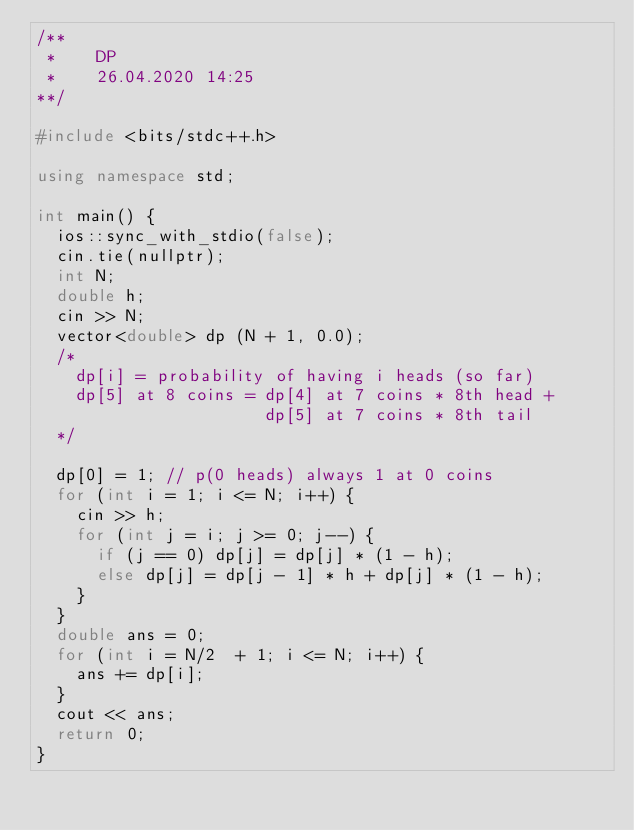<code> <loc_0><loc_0><loc_500><loc_500><_C++_>/**
 *    DP
 *    26.04.2020 14:25
**/

#include <bits/stdc++.h>

using namespace std;

int main() {
  ios::sync_with_stdio(false);
  cin.tie(nullptr);
  int N;
  double h;
  cin >> N;
  vector<double> dp (N + 1, 0.0);
  /*
    dp[i] = probability of having i heads (so far)
    dp[5] at 8 coins = dp[4] at 7 coins * 8th head + 
                       dp[5] at 7 coins * 8th tail
  */
  
  dp[0] = 1; // p(0 heads) always 1 at 0 coins
  for (int i = 1; i <= N; i++) {
    cin >> h;
    for (int j = i; j >= 0; j--) {
      if (j == 0) dp[j] = dp[j] * (1 - h);
      else dp[j] = dp[j - 1] * h + dp[j] * (1 - h);
    }
  }
  double ans = 0;
  for (int i = N/2  + 1; i <= N; i++) {
    ans += dp[i];
  }
  cout << ans;
  return 0;
}
</code> 